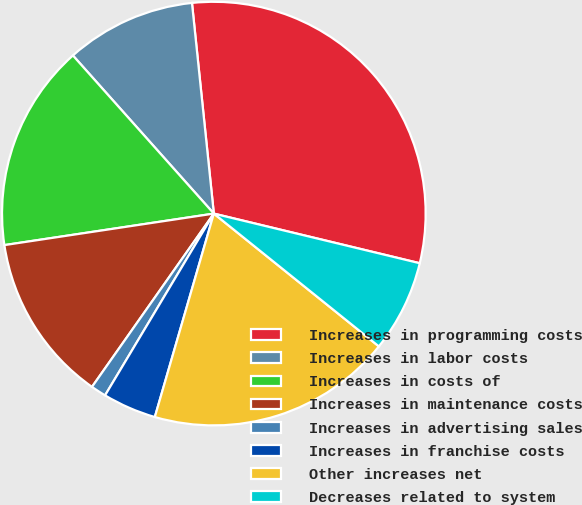Convert chart to OTSL. <chart><loc_0><loc_0><loc_500><loc_500><pie_chart><fcel>Increases in programming costs<fcel>Increases in labor costs<fcel>Increases in costs of<fcel>Increases in maintenance costs<fcel>Increases in advertising sales<fcel>Increases in franchise costs<fcel>Other increases net<fcel>Decreases related to system<nl><fcel>30.41%<fcel>9.94%<fcel>15.79%<fcel>12.87%<fcel>1.17%<fcel>4.09%<fcel>18.71%<fcel>7.02%<nl></chart> 